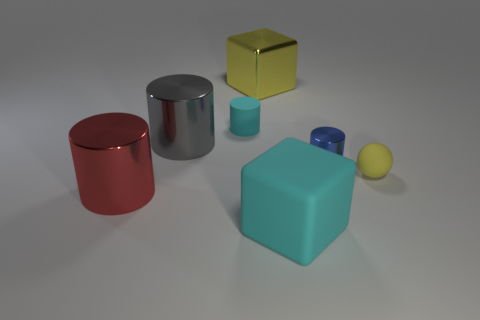There is a large red object; does it have the same shape as the cyan object in front of the blue metallic thing?
Your response must be concise. No. What number of matte things are big cyan things or cyan cylinders?
Provide a short and direct response. 2. Are there any small shiny cylinders that have the same color as the tiny rubber ball?
Your answer should be very brief. No. Is there a big yellow metal block?
Your answer should be very brief. Yes. Do the small yellow matte thing and the large yellow thing have the same shape?
Your response must be concise. No. How many big things are matte cylinders or green metallic things?
Ensure brevity in your answer.  0. What is the color of the matte ball?
Provide a short and direct response. Yellow. There is a yellow object on the right side of the big cube that is in front of the large red shiny cylinder; what is its shape?
Your response must be concise. Sphere. Is there a tiny blue cylinder that has the same material as the tiny cyan cylinder?
Give a very brief answer. No. There is a metallic thing in front of the yellow rubber thing; is it the same size as the tiny matte cylinder?
Your answer should be very brief. No. 